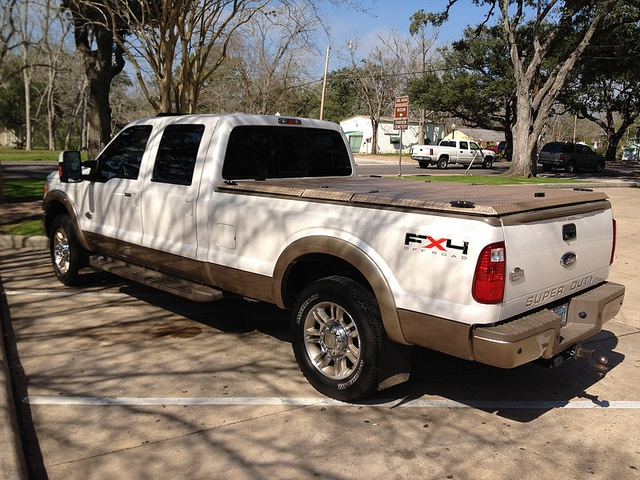Describe the objects in this image and their specific colors. I can see truck in gray, black, lightgray, and darkgray tones, truck in gray, white, black, and darkgray tones, car in gray and black tones, and car in gray, black, and navy tones in this image. 